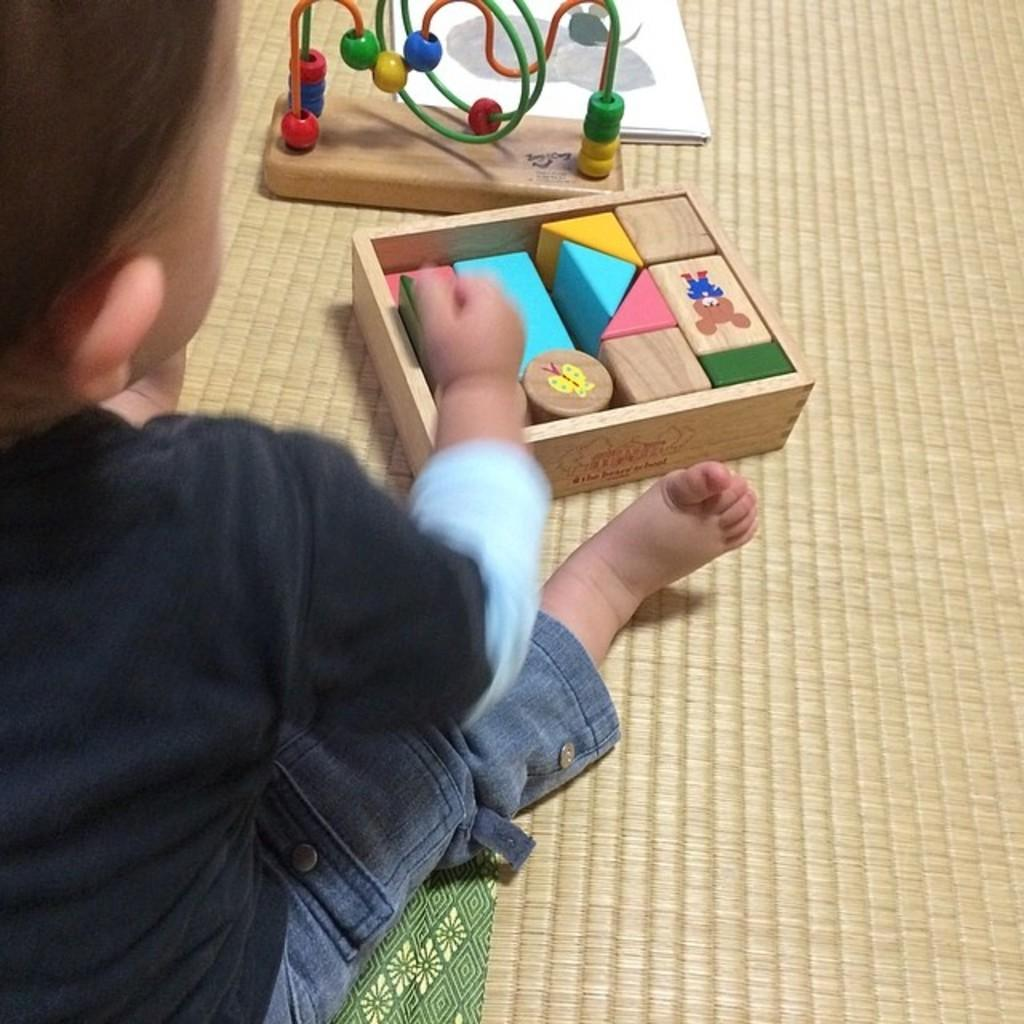Who is the main subject in the image? There is a small boy in the image. Where is the boy located in the image? The boy is on the left side of the image. What other objects or elements can be seen in the image? There are colorful shapes and papers in the image. What is the boy's memory like in the image? There is no information about the boy's memory in the image. The image only shows the boy's physical appearance and location, along with the presence of colorful shapes and papers. 